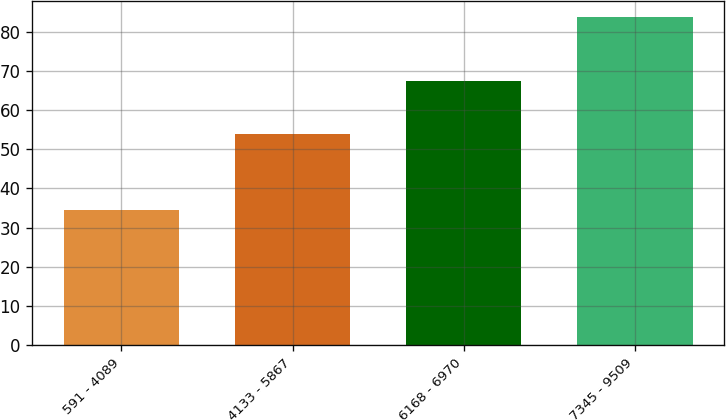Convert chart to OTSL. <chart><loc_0><loc_0><loc_500><loc_500><bar_chart><fcel>591 - 4089<fcel>4133 - 5867<fcel>6168 - 6970<fcel>7345 - 9509<nl><fcel>34.39<fcel>54.02<fcel>67.38<fcel>83.78<nl></chart> 